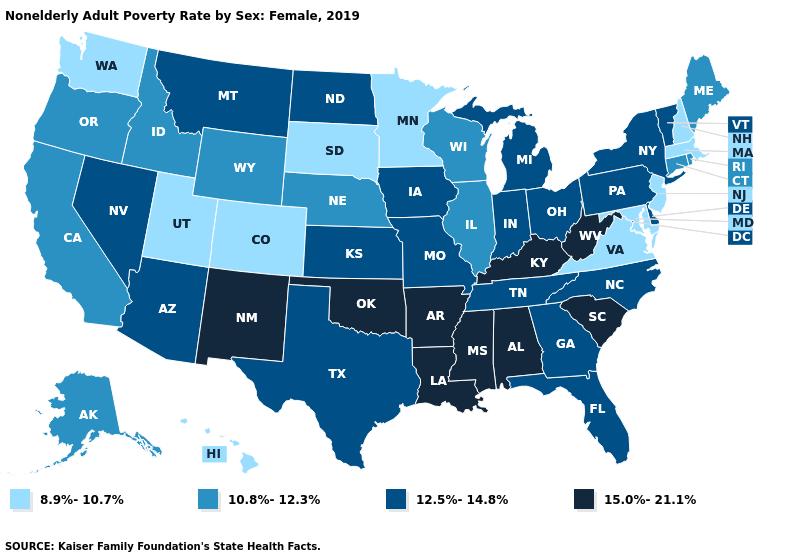Among the states that border Delaware , which have the highest value?
Short answer required. Pennsylvania. Name the states that have a value in the range 10.8%-12.3%?
Give a very brief answer. Alaska, California, Connecticut, Idaho, Illinois, Maine, Nebraska, Oregon, Rhode Island, Wisconsin, Wyoming. Name the states that have a value in the range 12.5%-14.8%?
Concise answer only. Arizona, Delaware, Florida, Georgia, Indiana, Iowa, Kansas, Michigan, Missouri, Montana, Nevada, New York, North Carolina, North Dakota, Ohio, Pennsylvania, Tennessee, Texas, Vermont. What is the value of Nebraska?
Write a very short answer. 10.8%-12.3%. Name the states that have a value in the range 15.0%-21.1%?
Answer briefly. Alabama, Arkansas, Kentucky, Louisiana, Mississippi, New Mexico, Oklahoma, South Carolina, West Virginia. Does Wisconsin have the highest value in the MidWest?
Concise answer only. No. Does Maryland have the lowest value in the South?
Quick response, please. Yes. Name the states that have a value in the range 12.5%-14.8%?
Concise answer only. Arizona, Delaware, Florida, Georgia, Indiana, Iowa, Kansas, Michigan, Missouri, Montana, Nevada, New York, North Carolina, North Dakota, Ohio, Pennsylvania, Tennessee, Texas, Vermont. Among the states that border West Virginia , does Virginia have the lowest value?
Short answer required. Yes. Name the states that have a value in the range 12.5%-14.8%?
Keep it brief. Arizona, Delaware, Florida, Georgia, Indiana, Iowa, Kansas, Michigan, Missouri, Montana, Nevada, New York, North Carolina, North Dakota, Ohio, Pennsylvania, Tennessee, Texas, Vermont. Name the states that have a value in the range 15.0%-21.1%?
Be succinct. Alabama, Arkansas, Kentucky, Louisiana, Mississippi, New Mexico, Oklahoma, South Carolina, West Virginia. What is the lowest value in the USA?
Write a very short answer. 8.9%-10.7%. Among the states that border West Virginia , does Maryland have the lowest value?
Write a very short answer. Yes. What is the highest value in the South ?
Write a very short answer. 15.0%-21.1%. Name the states that have a value in the range 10.8%-12.3%?
Be succinct. Alaska, California, Connecticut, Idaho, Illinois, Maine, Nebraska, Oregon, Rhode Island, Wisconsin, Wyoming. 